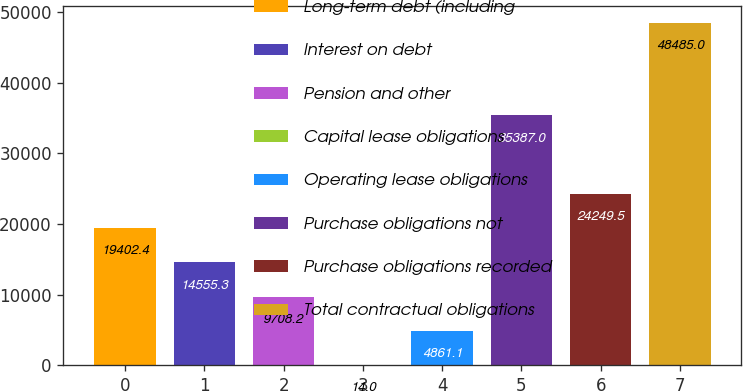<chart> <loc_0><loc_0><loc_500><loc_500><bar_chart><fcel>Long-term debt (including<fcel>Interest on debt<fcel>Pension and other<fcel>Capital lease obligations<fcel>Operating lease obligations<fcel>Purchase obligations not<fcel>Purchase obligations recorded<fcel>Total contractual obligations<nl><fcel>19402.4<fcel>14555.3<fcel>9708.2<fcel>14<fcel>4861.1<fcel>35387<fcel>24249.5<fcel>48485<nl></chart> 